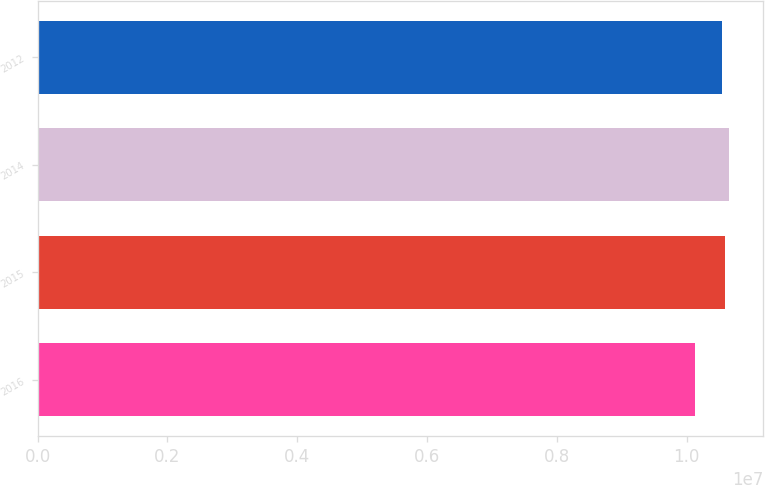Convert chart to OTSL. <chart><loc_0><loc_0><loc_500><loc_500><bar_chart><fcel>2016<fcel>2015<fcel>2014<fcel>2012<nl><fcel>1.0123e+07<fcel>1.0597e+07<fcel>1.06467e+07<fcel>1.0538e+07<nl></chart> 